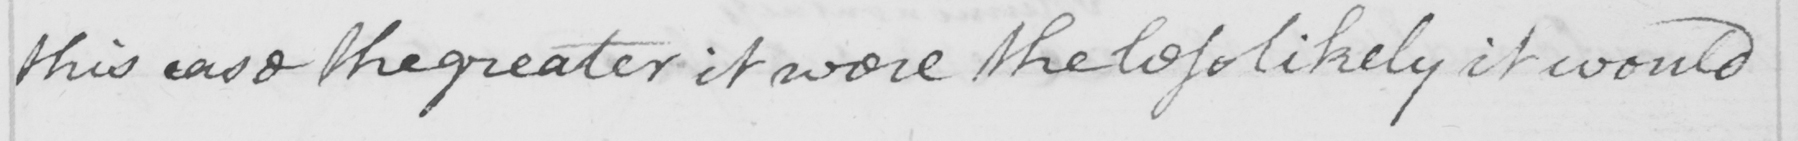Please transcribe the handwritten text in this image. this case the greater it were the less likely it would 